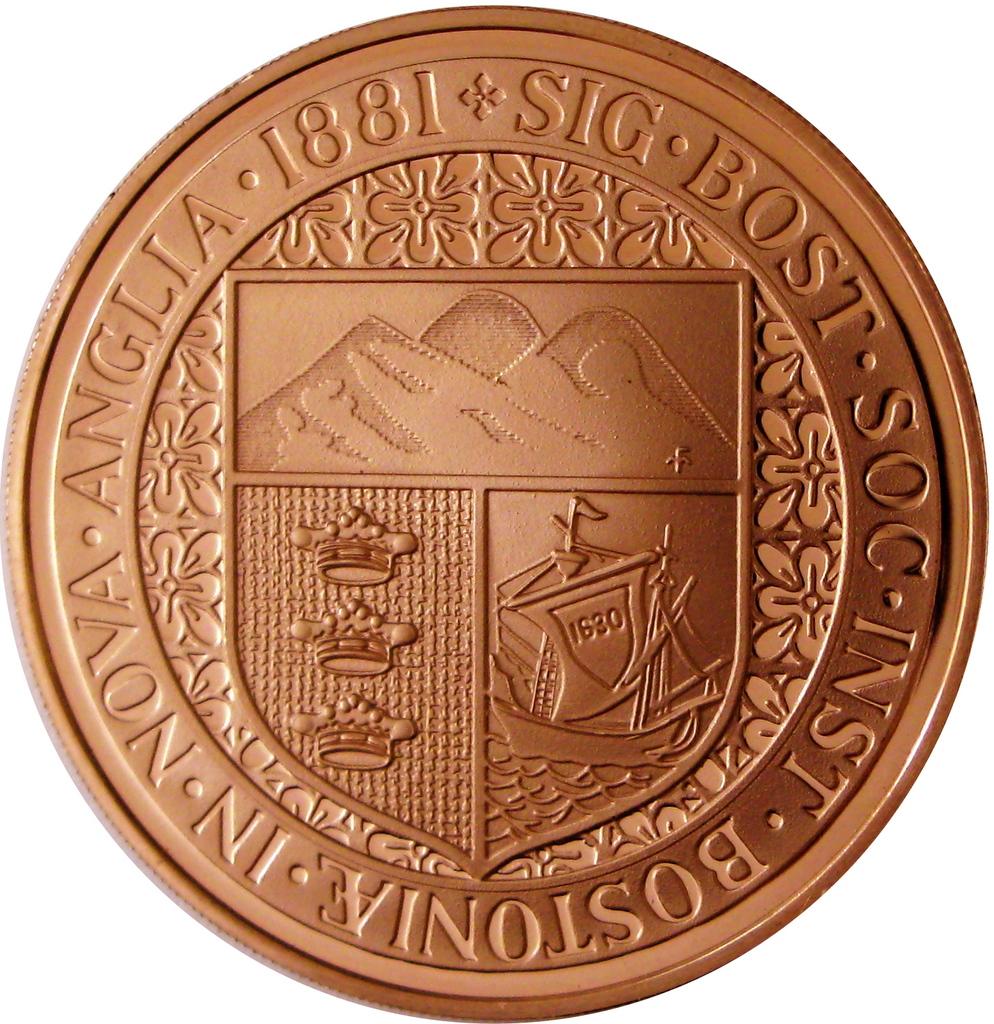What is the year on this coin?
Make the answer very short. 1881. What is the first letter after the year?
Give a very brief answer. S. 